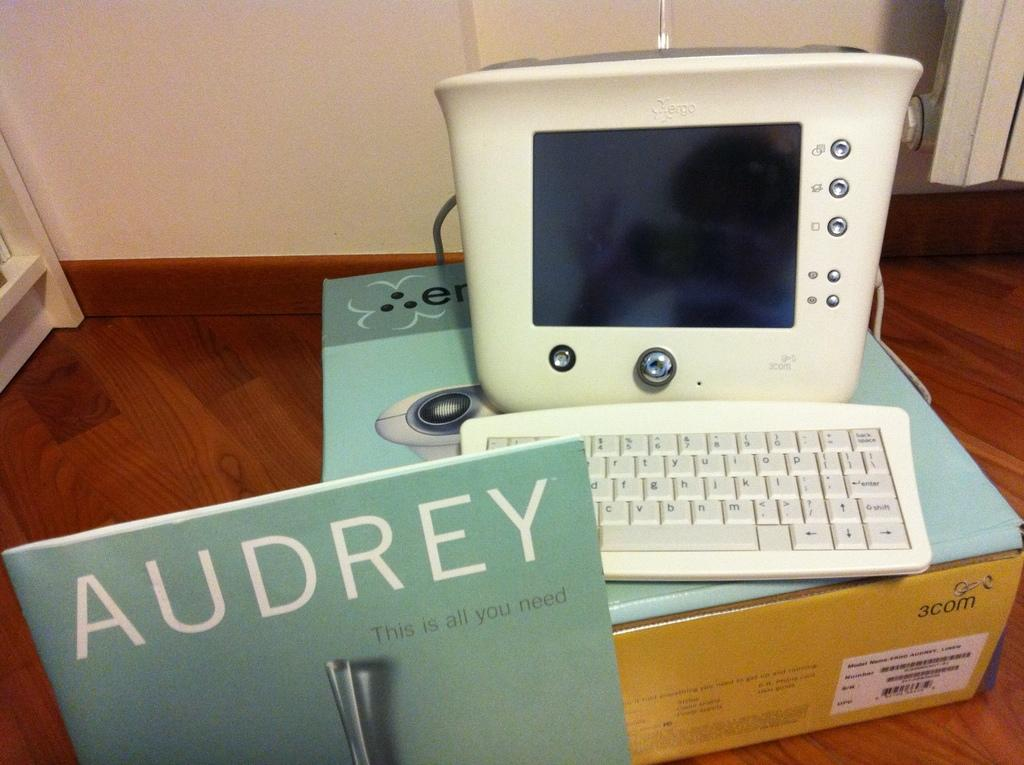<image>
Write a terse but informative summary of the picture. A book that says 'Audrey" on it in front of a computer. 